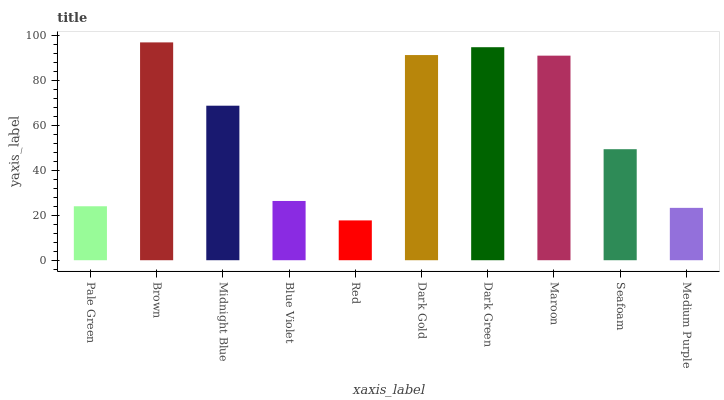Is Red the minimum?
Answer yes or no. Yes. Is Brown the maximum?
Answer yes or no. Yes. Is Midnight Blue the minimum?
Answer yes or no. No. Is Midnight Blue the maximum?
Answer yes or no. No. Is Brown greater than Midnight Blue?
Answer yes or no. Yes. Is Midnight Blue less than Brown?
Answer yes or no. Yes. Is Midnight Blue greater than Brown?
Answer yes or no. No. Is Brown less than Midnight Blue?
Answer yes or no. No. Is Midnight Blue the high median?
Answer yes or no. Yes. Is Seafoam the low median?
Answer yes or no. Yes. Is Maroon the high median?
Answer yes or no. No. Is Dark Green the low median?
Answer yes or no. No. 